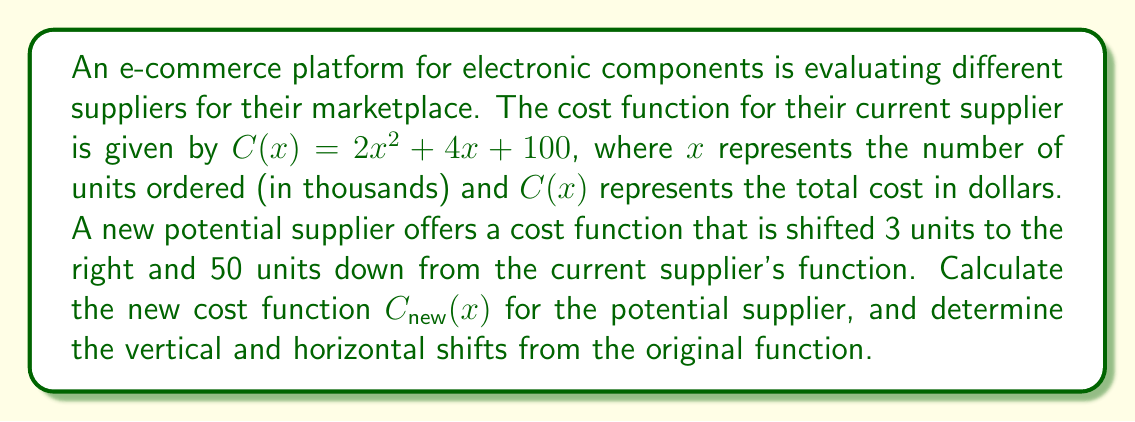Help me with this question. To solve this problem, we need to understand how vertical and horizontal shifts affect a function:

1. A horizontal shift of $h$ units right is represented by replacing $x$ with $(x - h)$ in the original function.
2. A vertical shift of $k$ units up is represented by adding $k$ to the original function.

Given:
- Original cost function: $C(x) = 2x^2 + 4x + 100$
- Horizontal shift: 3 units right
- Vertical shift: 50 units down

Step 1: Apply the horizontal shift
Replace $x$ with $(x - 3)$ in the original function:
$C_{shifted}(x) = 2(x-3)^2 + 4(x-3) + 100$

Step 2: Expand the squared term
$C_{shifted}(x) = 2(x^2 - 6x + 9) + 4x - 12 + 100$
$C_{shifted}(x) = 2x^2 - 12x + 18 + 4x - 12 + 100$
$C_{shifted}(x) = 2x^2 - 8x + 106$

Step 3: Apply the vertical shift
Subtract 50 from the expanded function:
$C_{new}(x) = 2x^2 - 8x + 106 - 50$
$C_{new}(x) = 2x^2 - 8x + 56$

Therefore, the new cost function for the potential supplier is $C_{new}(x) = 2x^2 - 8x + 56$.

The vertical shift is 50 units down, and the horizontal shift is 3 units right from the original function.
Answer: New cost function: $C_{new}(x) = 2x^2 - 8x + 56$
Vertical shift: 50 units down
Horizontal shift: 3 units right 